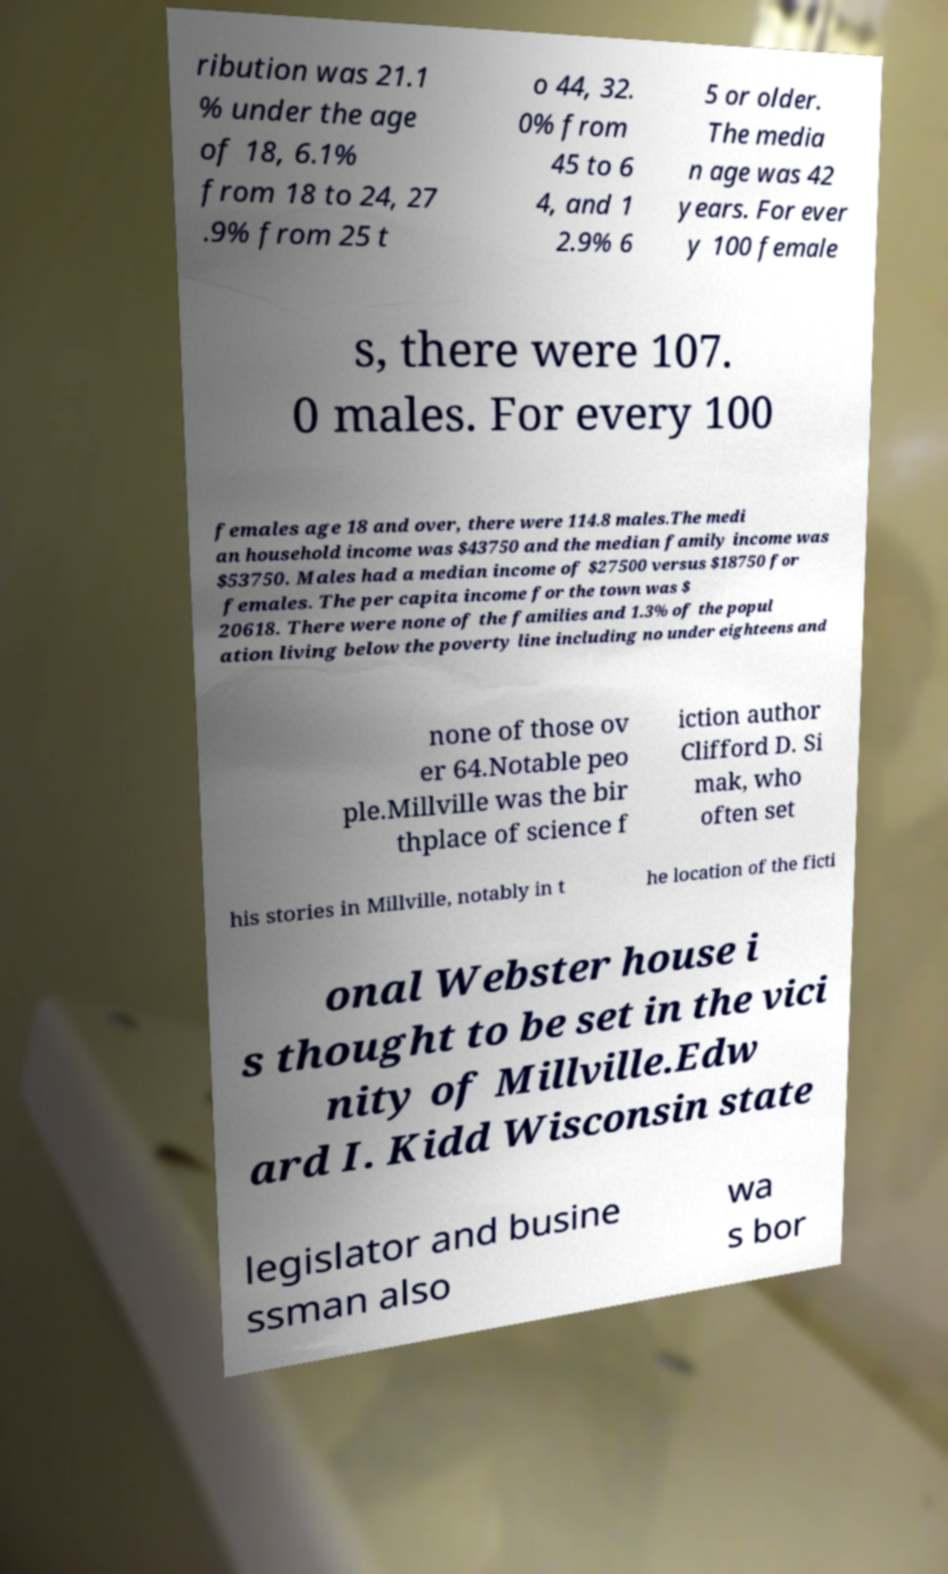Could you extract and type out the text from this image? ribution was 21.1 % under the age of 18, 6.1% from 18 to 24, 27 .9% from 25 t o 44, 32. 0% from 45 to 6 4, and 1 2.9% 6 5 or older. The media n age was 42 years. For ever y 100 female s, there were 107. 0 males. For every 100 females age 18 and over, there were 114.8 males.The medi an household income was $43750 and the median family income was $53750. Males had a median income of $27500 versus $18750 for females. The per capita income for the town was $ 20618. There were none of the families and 1.3% of the popul ation living below the poverty line including no under eighteens and none of those ov er 64.Notable peo ple.Millville was the bir thplace of science f iction author Clifford D. Si mak, who often set his stories in Millville, notably in t he location of the ficti onal Webster house i s thought to be set in the vici nity of Millville.Edw ard I. Kidd Wisconsin state legislator and busine ssman also wa s bor 